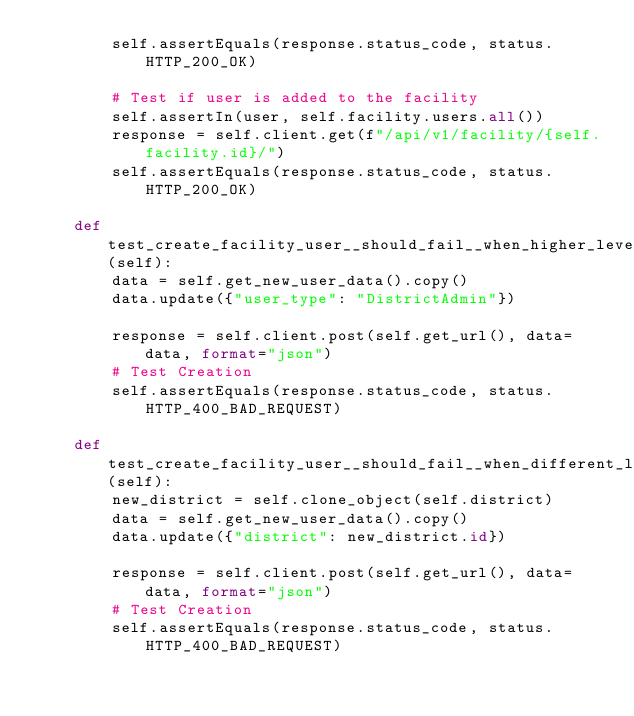<code> <loc_0><loc_0><loc_500><loc_500><_Python_>        self.assertEquals(response.status_code, status.HTTP_200_OK)

        # Test if user is added to the facility
        self.assertIn(user, self.facility.users.all())
        response = self.client.get(f"/api/v1/facility/{self.facility.id}/")
        self.assertEquals(response.status_code, status.HTTP_200_OK)

    def test_create_facility_user__should_fail__when_higher_level(self):
        data = self.get_new_user_data().copy()
        data.update({"user_type": "DistrictAdmin"})

        response = self.client.post(self.get_url(), data=data, format="json")
        # Test Creation
        self.assertEquals(response.status_code, status.HTTP_400_BAD_REQUEST)

    def test_create_facility_user__should_fail__when_different_location(self):
        new_district = self.clone_object(self.district)
        data = self.get_new_user_data().copy()
        data.update({"district": new_district.id})

        response = self.client.post(self.get_url(), data=data, format="json")
        # Test Creation
        self.assertEquals(response.status_code, status.HTTP_400_BAD_REQUEST)
</code> 